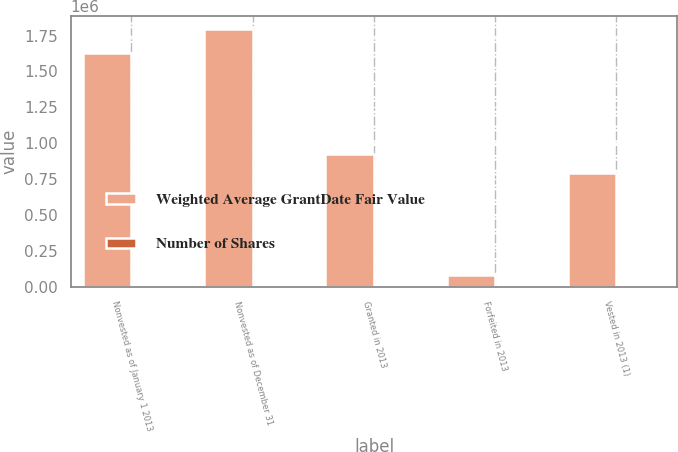<chart> <loc_0><loc_0><loc_500><loc_500><stacked_bar_chart><ecel><fcel>Nonvested as of January 1 2013<fcel>Nonvested as of December 31<fcel>Granted in 2013<fcel>Forfeited in 2013<fcel>Vested in 2013 (1)<nl><fcel>Weighted Average GrantDate Fair Value<fcel>1.62874e+06<fcel>1.79914e+06<fcel>924576<fcel>82629<fcel>792113<nl><fcel>Number of Shares<fcel>41.1<fcel>40.86<fcel>39.9<fcel>41.38<fcel>40.74<nl></chart> 